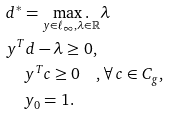<formula> <loc_0><loc_0><loc_500><loc_500>& d ^ { * } = \underset { y \in \ell _ { \infty } , \lambda \in \mathbb { R } } { \max . } \lambda \\ & y ^ { T } d - \lambda \geq 0 , \\ & \quad \, y ^ { T } c \geq 0 \quad , \forall \, c \in C _ { g } , \\ & \quad \, y _ { 0 } = 1 .</formula> 